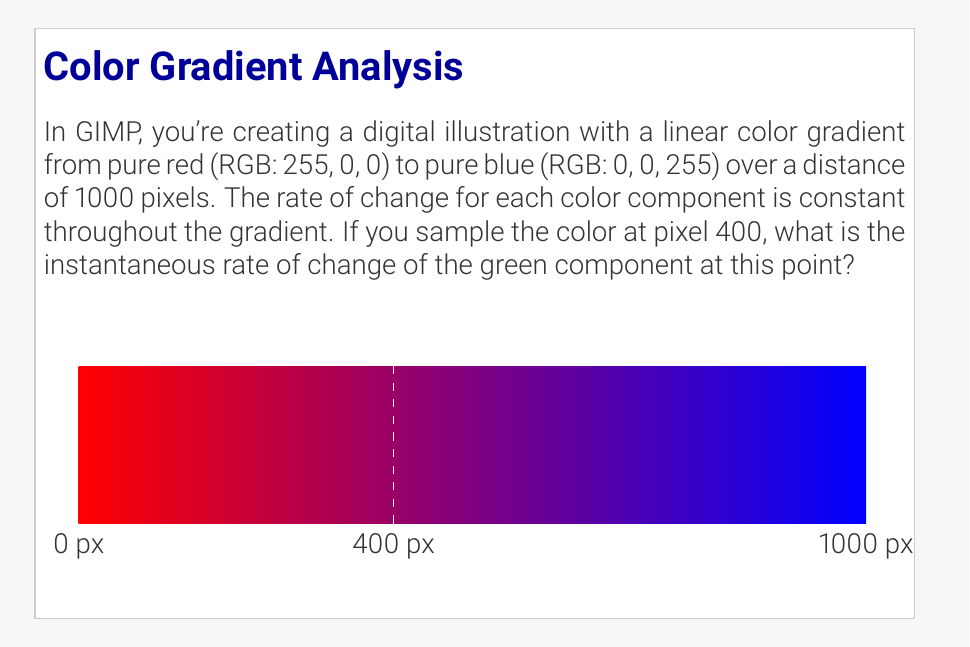Teach me how to tackle this problem. Let's approach this step-by-step:

1) We have a linear gradient from red (255, 0, 0) to blue (0, 0, 255) over 1000 pixels.

2) For a linear gradient, the rate of change for each color component is constant. We can find this rate using the formula:

   $$\text{Rate} = \frac{\text{Change in value}}{\text{Change in distance}}$$

3) For the red component:
   Initial value: 255
   Final value: 0
   Change: -255 over 1000 pixels
   Rate: $\frac{-255}{1000} = -0.255$ per pixel

4) For the blue component:
   Initial value: 0
   Final value: 255
   Change: 255 over 1000 pixels
   Rate: $\frac{255}{1000} = 0.255$ per pixel

5) For the green component:
   Initial value: 0
   Final value: 0
   Change: 0 over 1000 pixels
   Rate: $\frac{0}{1000} = 0$ per pixel

6) The question asks about the instantaneous rate of change of the green component at pixel 400. Since the rate is constant throughout the gradient, it's the same at any point, including pixel 400.

Therefore, the instantaneous rate of change of the green component at pixel 400 is 0 per pixel.
Answer: 0 per pixel 